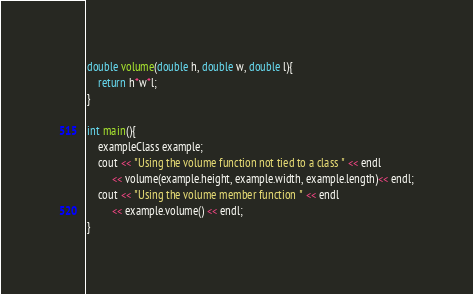<code> <loc_0><loc_0><loc_500><loc_500><_C++_>double volume(double h, double w, double l){
	return h*w*l;
}

int main(){
	exampleClass example;
	cout << "Using the volume function not tied to a class " << endl
		 << volume(example.height, example.width, example.length)<< endl;
	cout << "Using the volume member function " << endl
		 << example.volume() << endl;
}
</code> 